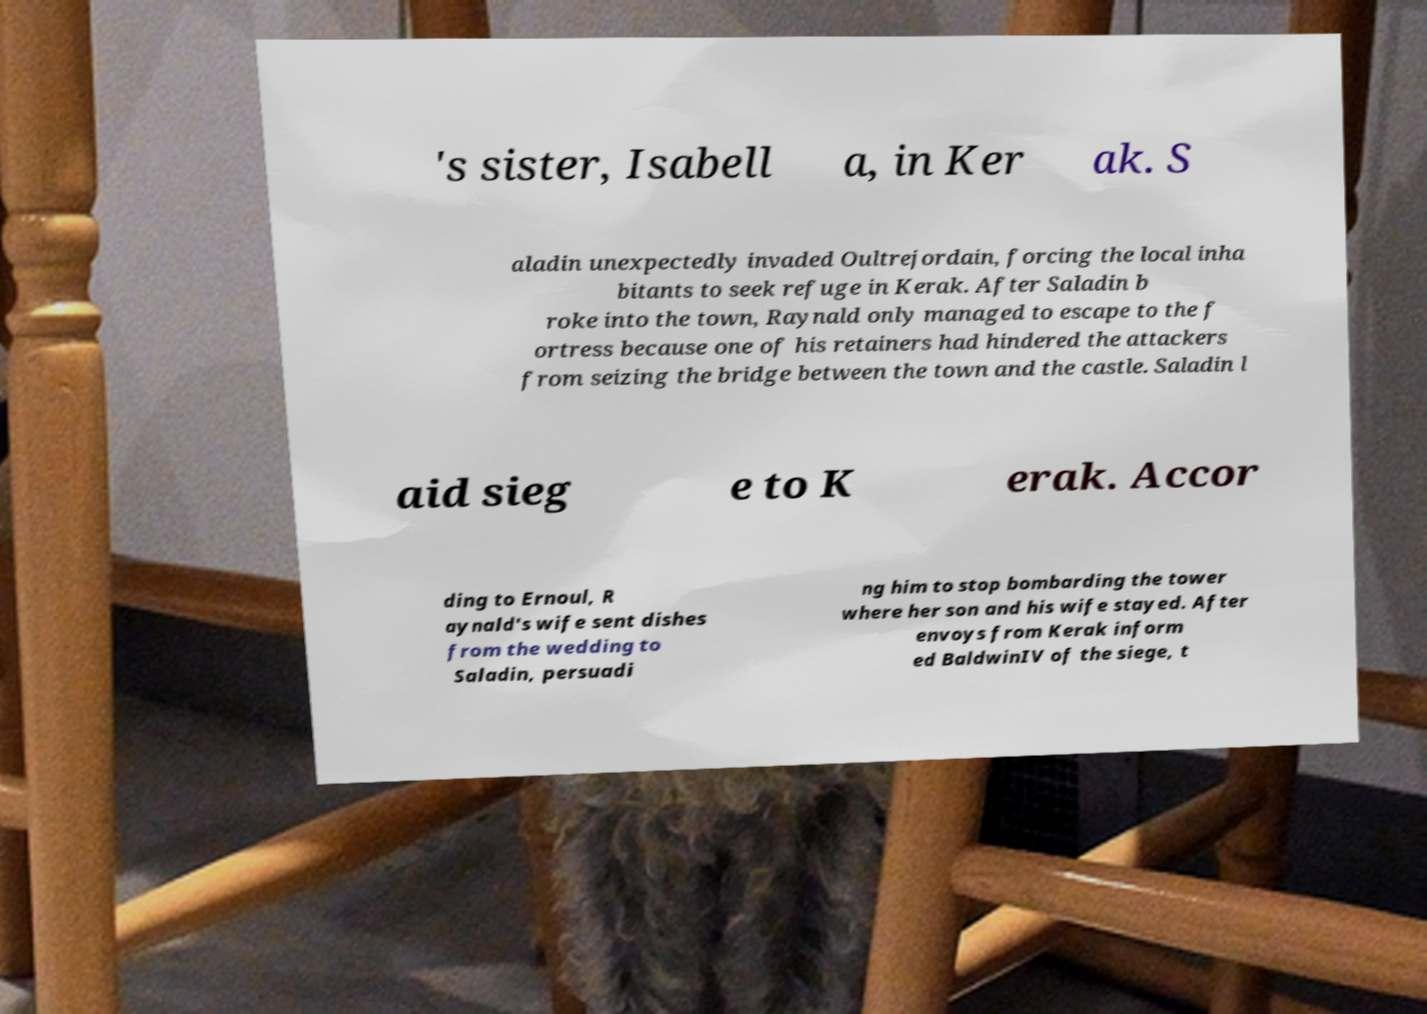I need the written content from this picture converted into text. Can you do that? 's sister, Isabell a, in Ker ak. S aladin unexpectedly invaded Oultrejordain, forcing the local inha bitants to seek refuge in Kerak. After Saladin b roke into the town, Raynald only managed to escape to the f ortress because one of his retainers had hindered the attackers from seizing the bridge between the town and the castle. Saladin l aid sieg e to K erak. Accor ding to Ernoul, R aynald's wife sent dishes from the wedding to Saladin, persuadi ng him to stop bombarding the tower where her son and his wife stayed. After envoys from Kerak inform ed BaldwinIV of the siege, t 